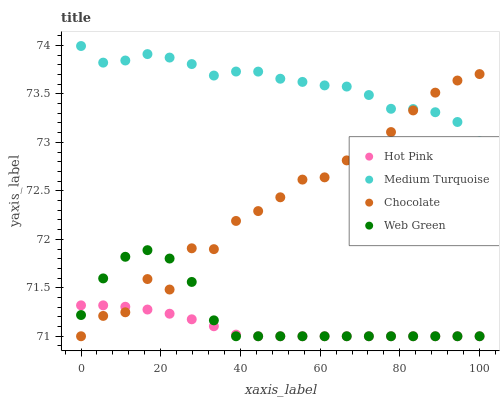Does Hot Pink have the minimum area under the curve?
Answer yes or no. Yes. Does Medium Turquoise have the maximum area under the curve?
Answer yes or no. Yes. Does Web Green have the minimum area under the curve?
Answer yes or no. No. Does Web Green have the maximum area under the curve?
Answer yes or no. No. Is Hot Pink the smoothest?
Answer yes or no. Yes. Is Chocolate the roughest?
Answer yes or no. Yes. Is Web Green the smoothest?
Answer yes or no. No. Is Web Green the roughest?
Answer yes or no. No. Does Hot Pink have the lowest value?
Answer yes or no. Yes. Does Medium Turquoise have the lowest value?
Answer yes or no. No. Does Medium Turquoise have the highest value?
Answer yes or no. Yes. Does Web Green have the highest value?
Answer yes or no. No. Is Hot Pink less than Medium Turquoise?
Answer yes or no. Yes. Is Medium Turquoise greater than Hot Pink?
Answer yes or no. Yes. Does Web Green intersect Chocolate?
Answer yes or no. Yes. Is Web Green less than Chocolate?
Answer yes or no. No. Is Web Green greater than Chocolate?
Answer yes or no. No. Does Hot Pink intersect Medium Turquoise?
Answer yes or no. No. 